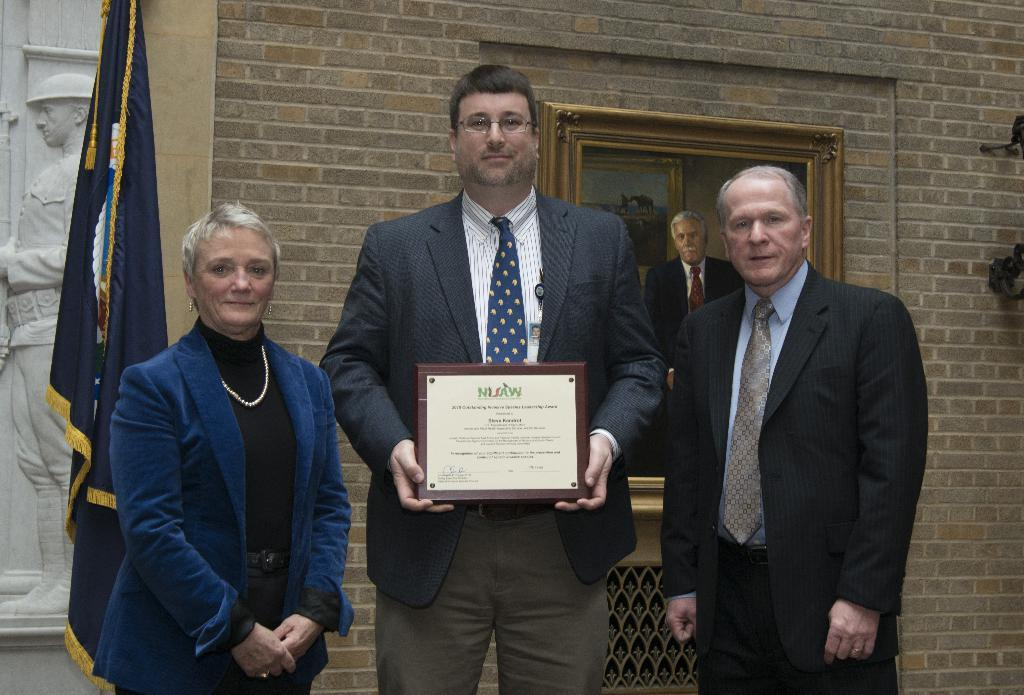How many people are present in the image? There are many persons standing in the image. What can be seen in the background of the image? There is a photo frame, a flag, a sculpture, and a wall in the background of the image. What type of house is visible in the background of the image? There is no house visible in the background of the image. What chess pieces can be seen on the table in the image? There is no chess set or any chess pieces present in the image. 